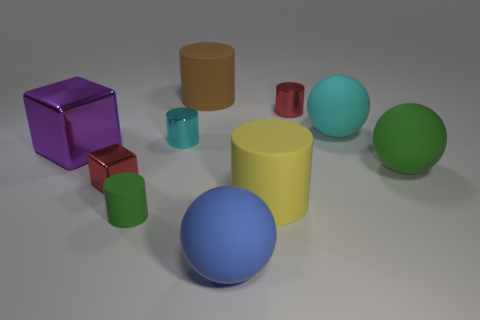Subtract all green cylinders. How many cylinders are left? 4 Subtract all yellow matte cylinders. How many cylinders are left? 4 Subtract all purple cylinders. Subtract all brown cubes. How many cylinders are left? 5 Subtract all spheres. How many objects are left? 7 Subtract all red metal things. Subtract all cylinders. How many objects are left? 3 Add 2 rubber cylinders. How many rubber cylinders are left? 5 Add 9 big red cylinders. How many big red cylinders exist? 9 Subtract 0 purple cylinders. How many objects are left? 10 